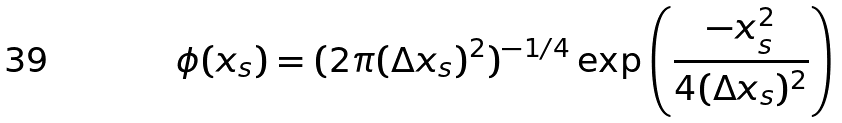<formula> <loc_0><loc_0><loc_500><loc_500>\phi ( x _ { s } ) = ( 2 \pi ( \Delta x _ { s } ) ^ { 2 } ) ^ { - 1 / 4 } \exp \left ( \frac { - x _ { s } ^ { 2 } } { 4 ( \Delta x _ { s } ) ^ { 2 } } \right )</formula> 